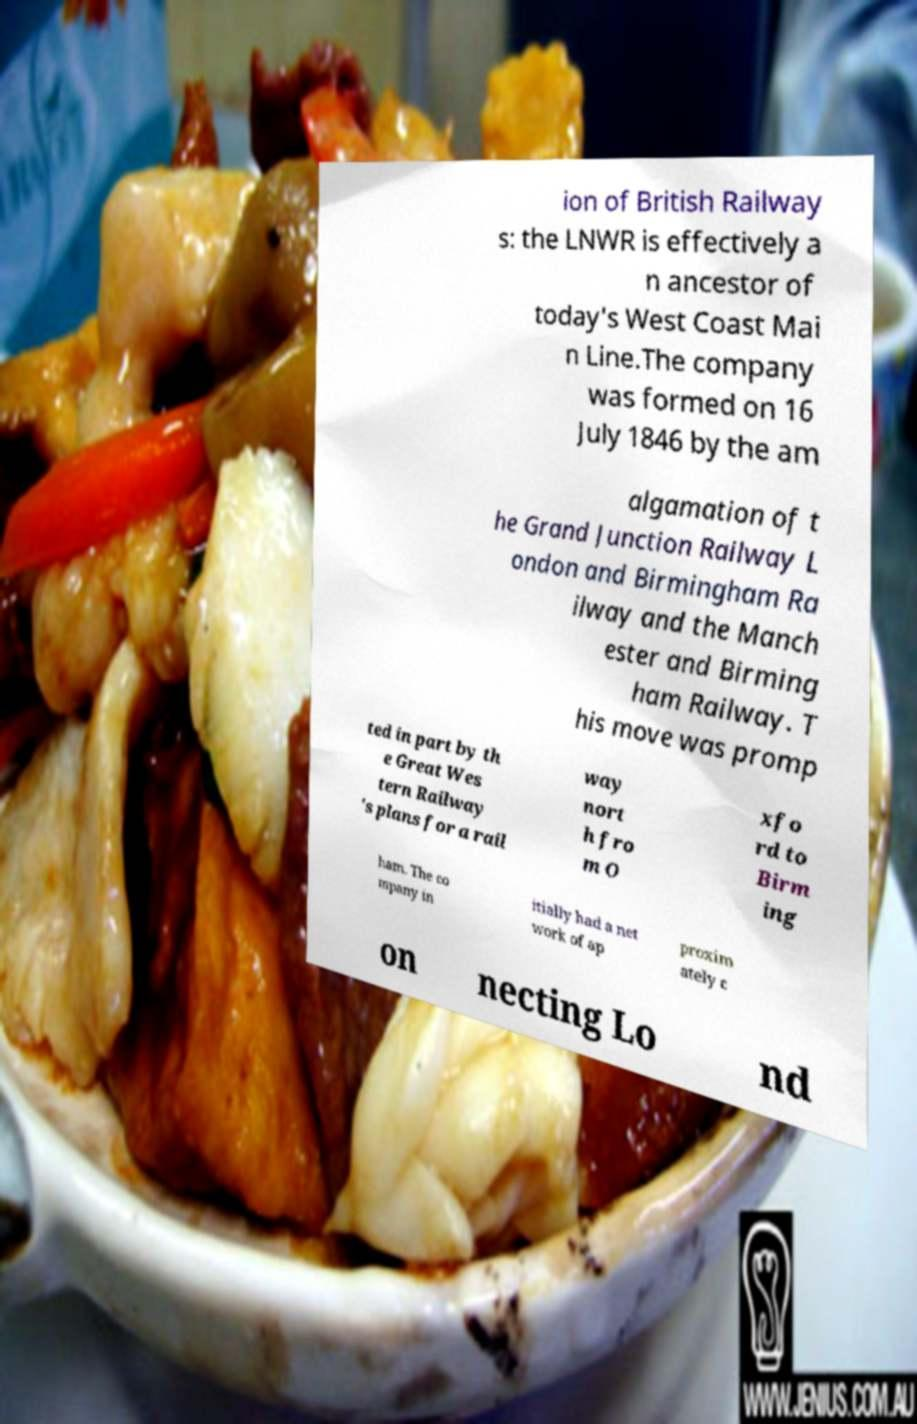Can you accurately transcribe the text from the provided image for me? ion of British Railway s: the LNWR is effectively a n ancestor of today's West Coast Mai n Line.The company was formed on 16 July 1846 by the am algamation of t he Grand Junction Railway L ondon and Birmingham Ra ilway and the Manch ester and Birming ham Railway. T his move was promp ted in part by th e Great Wes tern Railway 's plans for a rail way nort h fro m O xfo rd to Birm ing ham. The co mpany in itially had a net work of ap proxim ately c on necting Lo nd 